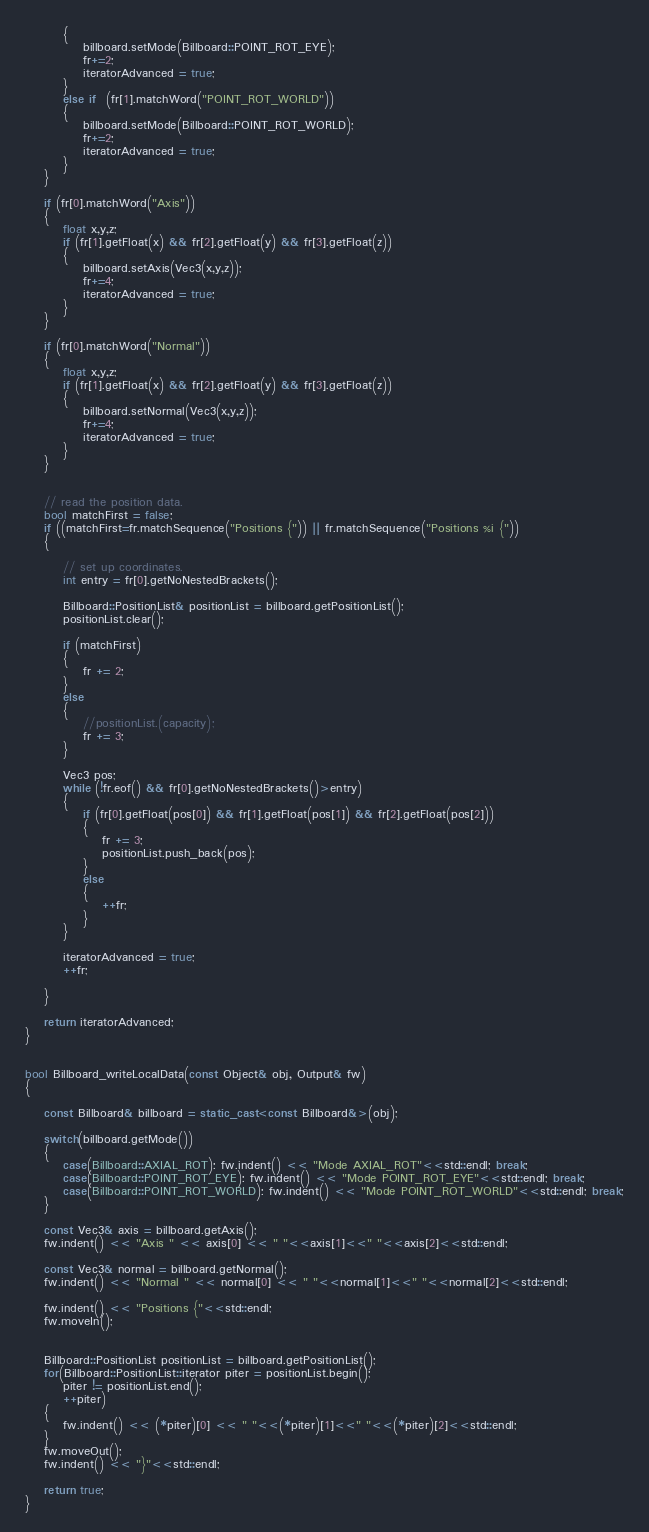Convert code to text. <code><loc_0><loc_0><loc_500><loc_500><_C++_>        {
            billboard.setMode(Billboard::POINT_ROT_EYE);
            fr+=2;
            iteratorAdvanced = true;
        }
        else if  (fr[1].matchWord("POINT_ROT_WORLD"))
        {
            billboard.setMode(Billboard::POINT_ROT_WORLD);
            fr+=2;
            iteratorAdvanced = true;
        }
    }

    if (fr[0].matchWord("Axis"))
    {
        float x,y,z;
        if (fr[1].getFloat(x) && fr[2].getFloat(y) && fr[3].getFloat(z))
        {
            billboard.setAxis(Vec3(x,y,z));
            fr+=4;
            iteratorAdvanced = true;
        }
    }

    if (fr[0].matchWord("Normal"))
    {
        float x,y,z;
        if (fr[1].getFloat(x) && fr[2].getFloat(y) && fr[3].getFloat(z))
        {
            billboard.setNormal(Vec3(x,y,z));
            fr+=4;
            iteratorAdvanced = true;
        }
    }


    // read the position data.
    bool matchFirst = false;
    if ((matchFirst=fr.matchSequence("Positions {")) || fr.matchSequence("Positions %i {"))
    {

        // set up coordinates.
        int entry = fr[0].getNoNestedBrackets();

        Billboard::PositionList& positionList = billboard.getPositionList();
        positionList.clear();
        
        if (matchFirst)
        {
            fr += 2;
        }
        else
        {
            //positionList.(capacity);
            fr += 3;
        }

        Vec3 pos;
        while (!fr.eof() && fr[0].getNoNestedBrackets()>entry)
        {
            if (fr[0].getFloat(pos[0]) && fr[1].getFloat(pos[1]) && fr[2].getFloat(pos[2]))
            {
                fr += 3;
                positionList.push_back(pos);
            }
            else
            {
                ++fr;
            }
        }

        iteratorAdvanced = true;
        ++fr;

    }

    return iteratorAdvanced;
}


bool Billboard_writeLocalData(const Object& obj, Output& fw)
{

    const Billboard& billboard = static_cast<const Billboard&>(obj);

    switch(billboard.getMode())
    {
        case(Billboard::AXIAL_ROT): fw.indent() << "Mode AXIAL_ROT"<<std::endl; break;
        case(Billboard::POINT_ROT_EYE): fw.indent() << "Mode POINT_ROT_EYE"<<std::endl; break;
        case(Billboard::POINT_ROT_WORLD): fw.indent() << "Mode POINT_ROT_WORLD"<<std::endl; break;
    }

    const Vec3& axis = billboard.getAxis();
    fw.indent() << "Axis " << axis[0] << " "<<axis[1]<<" "<<axis[2]<<std::endl;

    const Vec3& normal = billboard.getNormal();
    fw.indent() << "Normal " << normal[0] << " "<<normal[1]<<" "<<normal[2]<<std::endl;

    fw.indent() << "Positions {"<<std::endl;
    fw.moveIn();


    Billboard::PositionList positionList = billboard.getPositionList();
    for(Billboard::PositionList::iterator piter = positionList.begin();
        piter != positionList.end();
        ++piter)
    {
        fw.indent() << (*piter)[0] << " "<<(*piter)[1]<<" "<<(*piter)[2]<<std::endl;
    }
    fw.moveOut();
    fw.indent() << "}"<<std::endl;

    return true;
}
</code> 